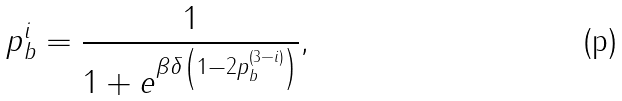Convert formula to latex. <formula><loc_0><loc_0><loc_500><loc_500>p ^ { i } _ { b } = \frac { 1 } { 1 + e ^ { \beta \delta \left ( 1 - 2 p ^ { \left ( 3 - i \right ) } _ { b } \right ) } } ,</formula> 